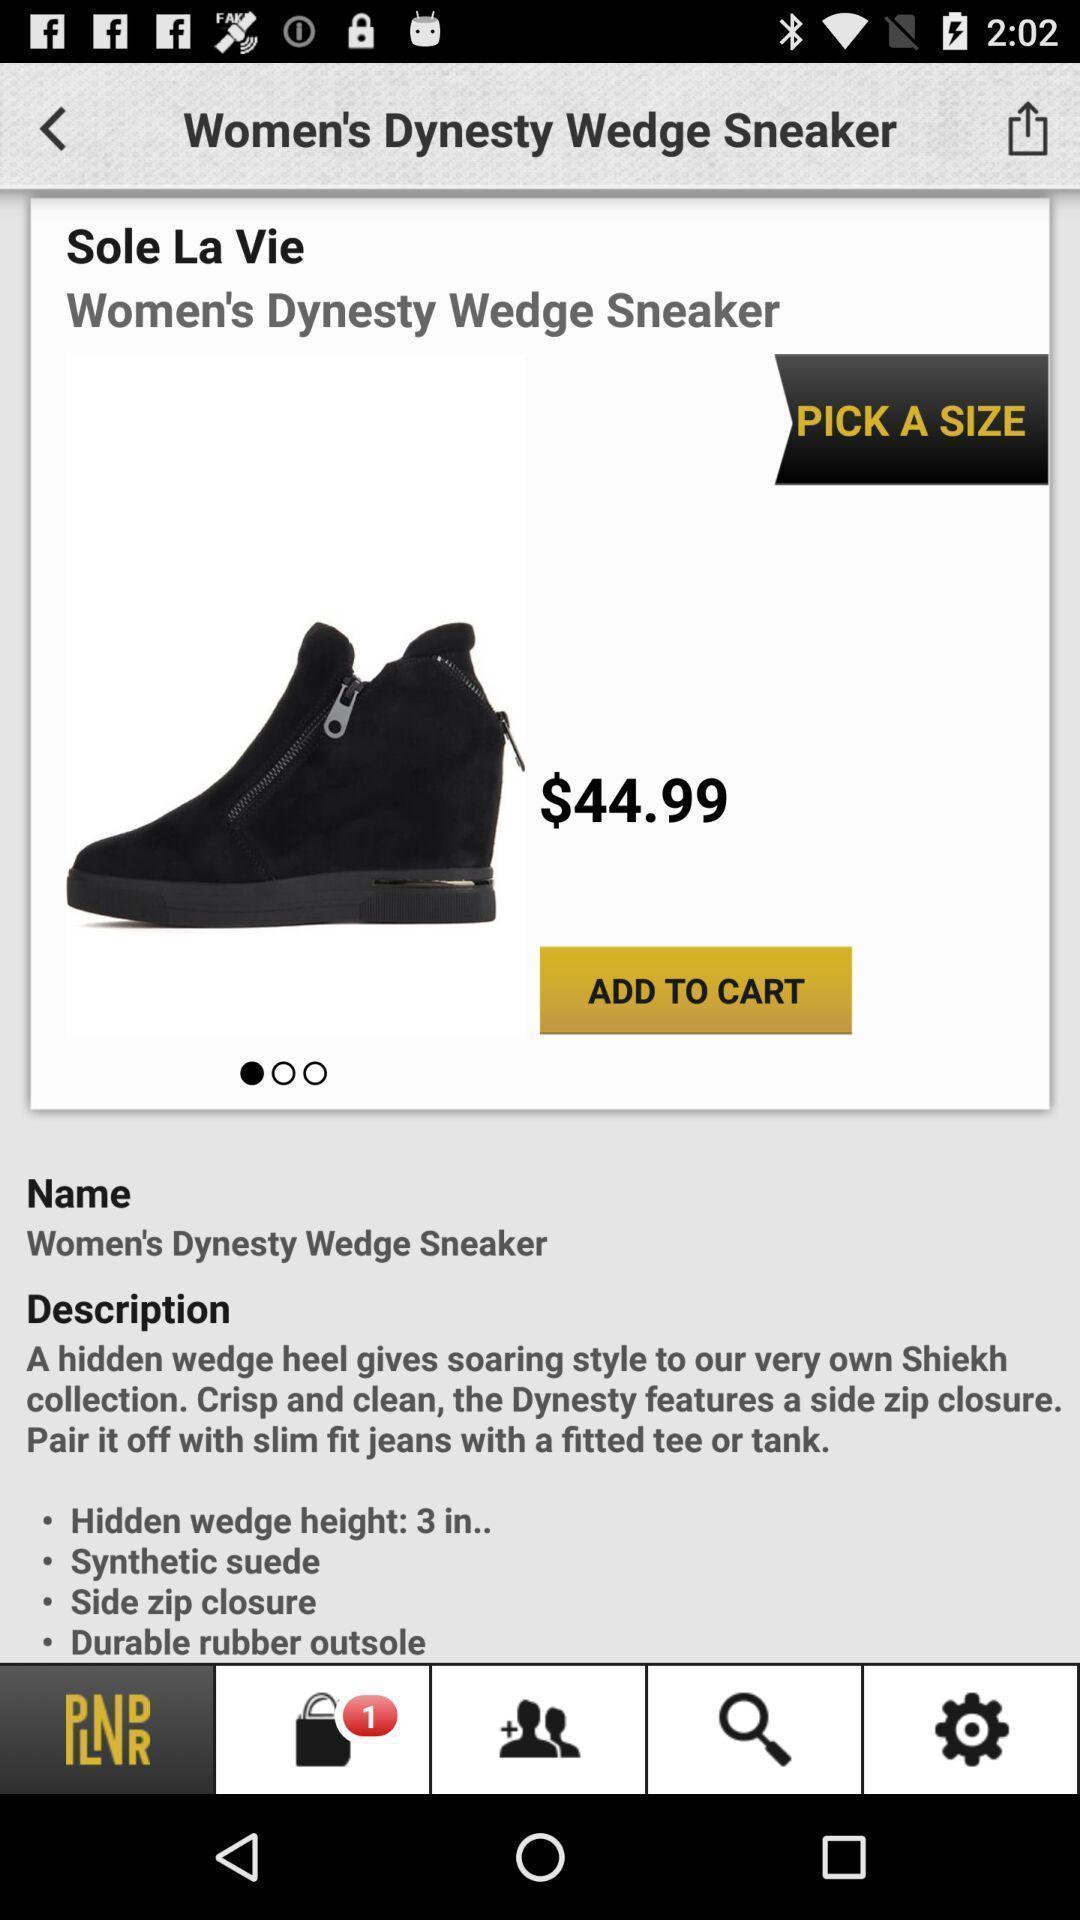What details can you identify in this image? Shoes page of a women footwear app. 